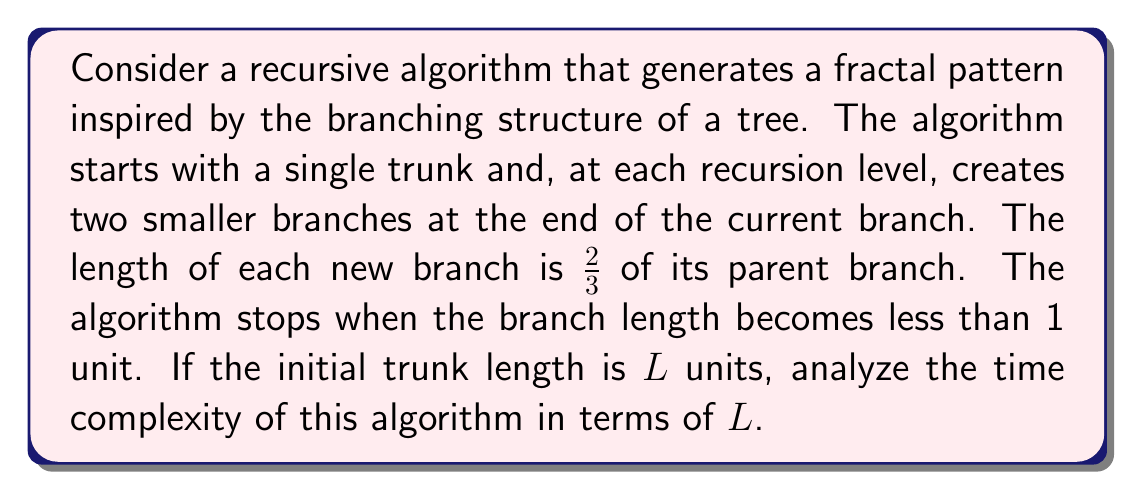Could you help me with this problem? Let's approach this step-by-step:

1) First, we need to determine how many levels of recursion will occur before the algorithm stops. Let's call this number $n$.

2) At each level, the branch length is $\frac{2}{3}$ of the previous level. So we can express this as:

   $L \cdot (\frac{2}{3})^n < 1$

3) Taking the logarithm of both sides:

   $n \cdot \log(\frac{2}{3}) + \log(L) < 0$

4) Solving for $n$:

   $n > \frac{-\log(L)}{\log(\frac{2}{3})} = \frac{\log(L)}{\log(\frac{3}{2})}$

5) Therefore, the number of levels is $O(\log(L))$.

6) Now, at each level, the number of branches doubles. So the number of operations at each level follows this pattern:

   Level 0: 1
   Level 1: 2
   Level 2: 4
   ...
   Level $n$: $2^n$

7) The total number of operations is the sum of this geometric series:

   $1 + 2 + 4 + ... + 2^n = 2^{n+1} - 1$

8) We know that $n = O(\log(L))$, so the total number of operations is:

   $2^{O(\log(L))} - 1 = O(L) - 1 = O(L)$

Therefore, the time complexity of this algorithm is $O(L)$.
Answer: The time complexity of the recursive fractal generation algorithm is $O(L)$, where $L$ is the initial trunk length. 